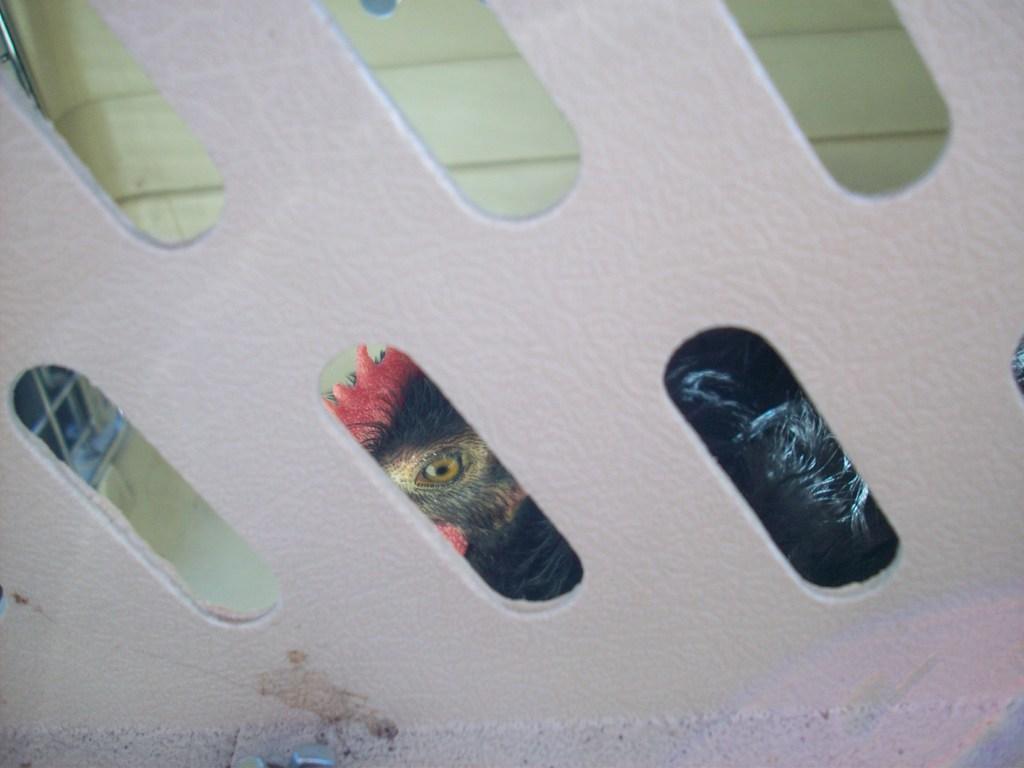Describe this image in one or two sentences. In this image, we can see a design wall. 